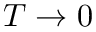<formula> <loc_0><loc_0><loc_500><loc_500>T \rightarrow 0</formula> 